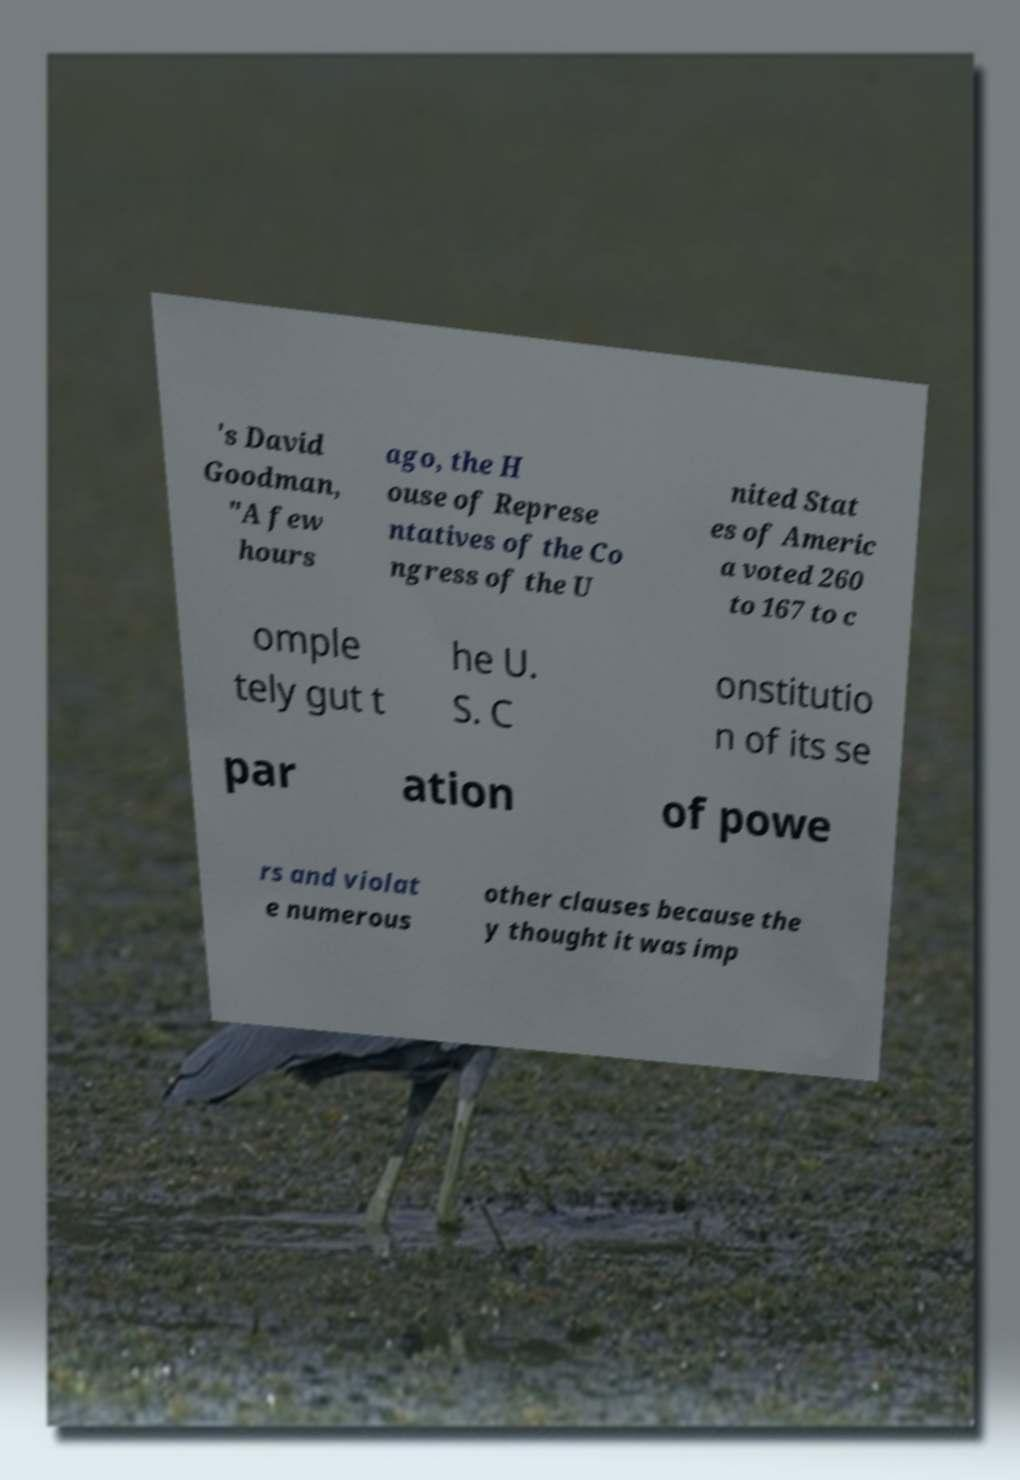Please identify and transcribe the text found in this image. 's David Goodman, "A few hours ago, the H ouse of Represe ntatives of the Co ngress of the U nited Stat es of Americ a voted 260 to 167 to c omple tely gut t he U. S. C onstitutio n of its se par ation of powe rs and violat e numerous other clauses because the y thought it was imp 